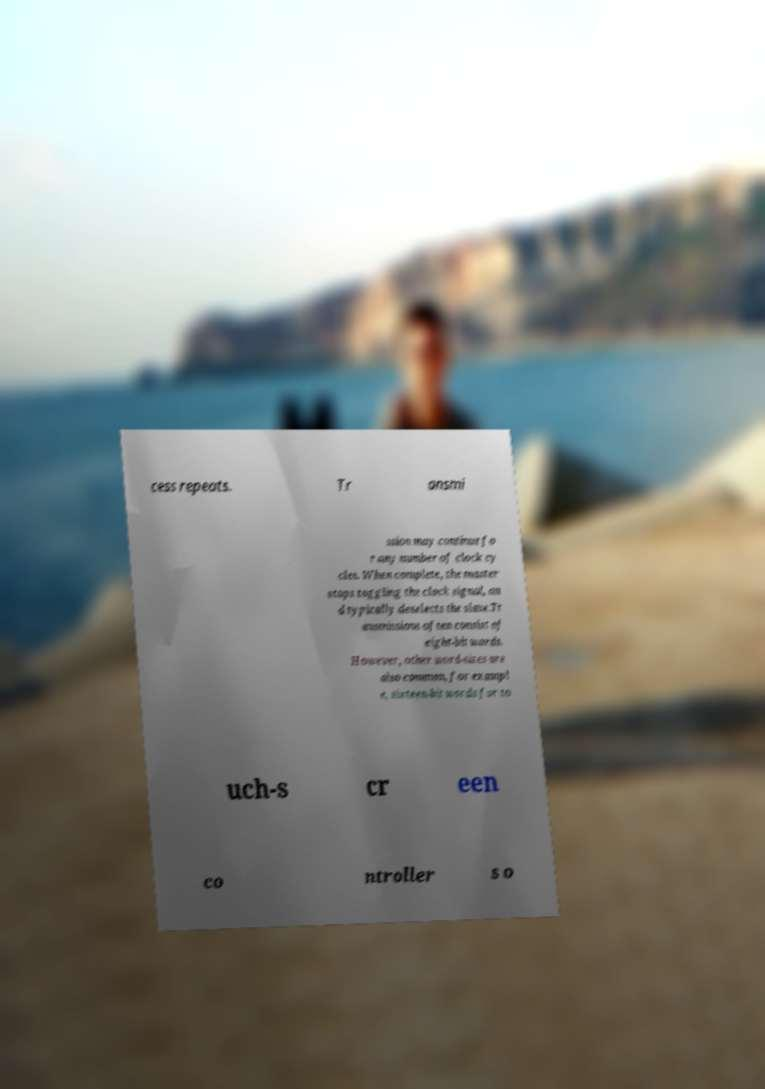Please identify and transcribe the text found in this image. cess repeats. Tr ansmi ssion may continue fo r any number of clock cy cles. When complete, the master stops toggling the clock signal, an d typically deselects the slave.Tr ansmissions often consist of eight-bit words. However, other word-sizes are also common, for exampl e, sixteen-bit words for to uch-s cr een co ntroller s o 